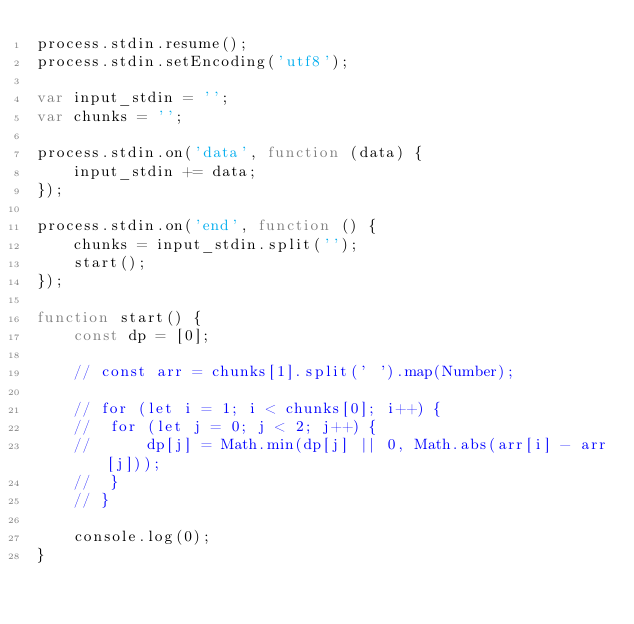Convert code to text. <code><loc_0><loc_0><loc_500><loc_500><_JavaScript_>process.stdin.resume();
process.stdin.setEncoding('utf8');

var input_stdin = '';
var chunks = '';

process.stdin.on('data', function (data) {
    input_stdin += data;
});

process.stdin.on('end', function () {
    chunks = input_stdin.split('');
    start();    
});

function start() {
	const dp = [0];

	// const arr = chunks[1].split(' ').map(Number);

	// for (let i = 1; i < chunks[0]; i++) {
	// 	for (let j = 0; j < 2; j++) {
	// 		dp[j] = Math.min(dp[j] || 0, Math.abs(arr[i] - arr[j]));
	// 	}
	// }

	console.log(0);
}
</code> 